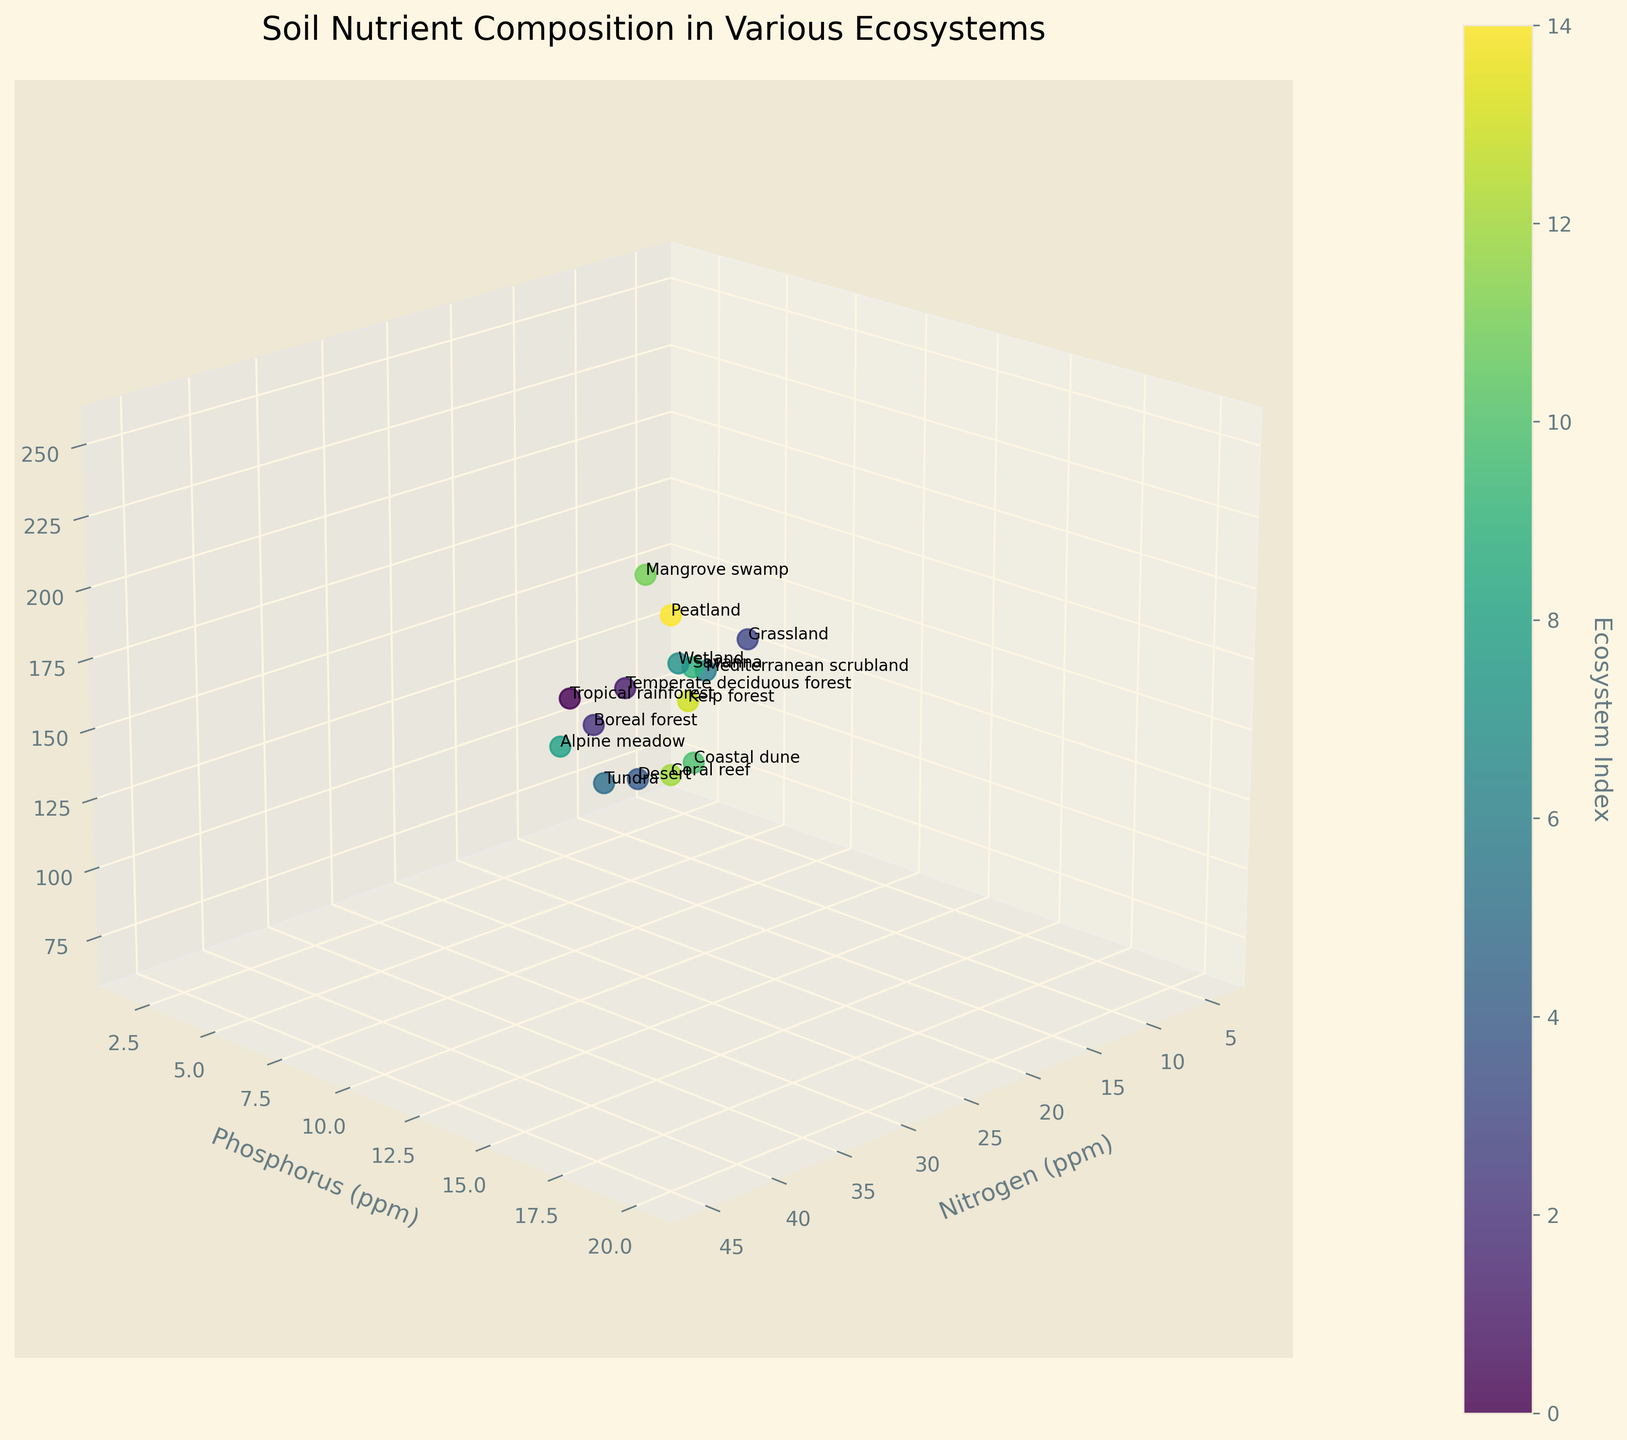What is the ecosystem with the highest nitrogen content? Look for the highest value on the Nitrogen axis and identify the corresponding ecosystem label. The highest nitrogen content is at 45 ppm, corresponding to Peatland.
Answer: Peatland What is the relationship between potassium levels and the desert ecosystem? Find the data point labeled as the Desert ecosystem. Identify its location on the Potassium axis. Desert has a potassium level of 80 ppm.
Answer: 80 ppm Which ecosystem has the lowest phosphorus content, and how much is it? Identify the lowest value on the Phosphorus axis and its corresponding label. The lowest phosphorus content is 2 ppm, corresponding to Coral reef.
Answer: Coral reef with 2 ppm Compare the nitrogen levels of Grassland and Savanna ecosystems. Which one has higher nitrogen, and by how much? Look at the nitrogen levels for both the Grassland and Savanna. Grassland has 28 ppm, and Savanna has 30 ppm. The difference is 30 - 28 = 2 ppm, so Savanna has 2 ppm higher than Grassland.
Answer: Savanna by 2 ppm What's the average phosphorus content across all ecosystems? Sum all the phosphorus contents and divide by the number of ecosystems (15). Sum = 12 + 8 + 5 + 15 + 3 + 4 + 10 + 18 + 7 + 14 + 6 + 16 + 2 + 4 + 20 = 144. Average = 144 / 15 = 9.6 ppm.
Answer: 9.6 ppm Which ecosystem has the highest potassium content, and how much is it? Identify the highest value on the Potassium axis and identify the corresponding ecosystem label. The highest potassium content is at 250 ppm, corresponding to Peatland.
Answer: Peatland with 250 ppm Compare the phosphorus content between Tundra and Kelp forest. Which one is higher and by how much? Look at the phosphorus content for both Tundra (4 ppm) and Kelp forest (4 ppm). They are equal, so neither is higher.
Answer: They are equal What is the ecosystem with the lowest nitrogen content? Identify the lowest value on the Nitrogen axis and its corresponding ecosystem label. The lowest nitrogen content is 5 ppm, corresponding to Coral reef.
Answer: Coral reef Which ecosystems have a potassium content above 200 ppm? Look at values on the Potassium axis above 200 ppm and identify the corresponding ecosystem labels. Ecosystems with potassium above 200 ppm are Wetland (220 ppm), Mangrove swamp (240 ppm), and Peatland (250 ppm).
Answer: Wetland, Mangrove swamp, Peatland What's the range of phosphorus content in the Boreal forest compared to the Tropical rainforest? Identify the phosphorus content of Boreal forest (5 ppm) and Tropical rainforest (12 ppm). Calculate the range/difference: 12 - 5 = 7 ppm.
Answer: 7 ppm 